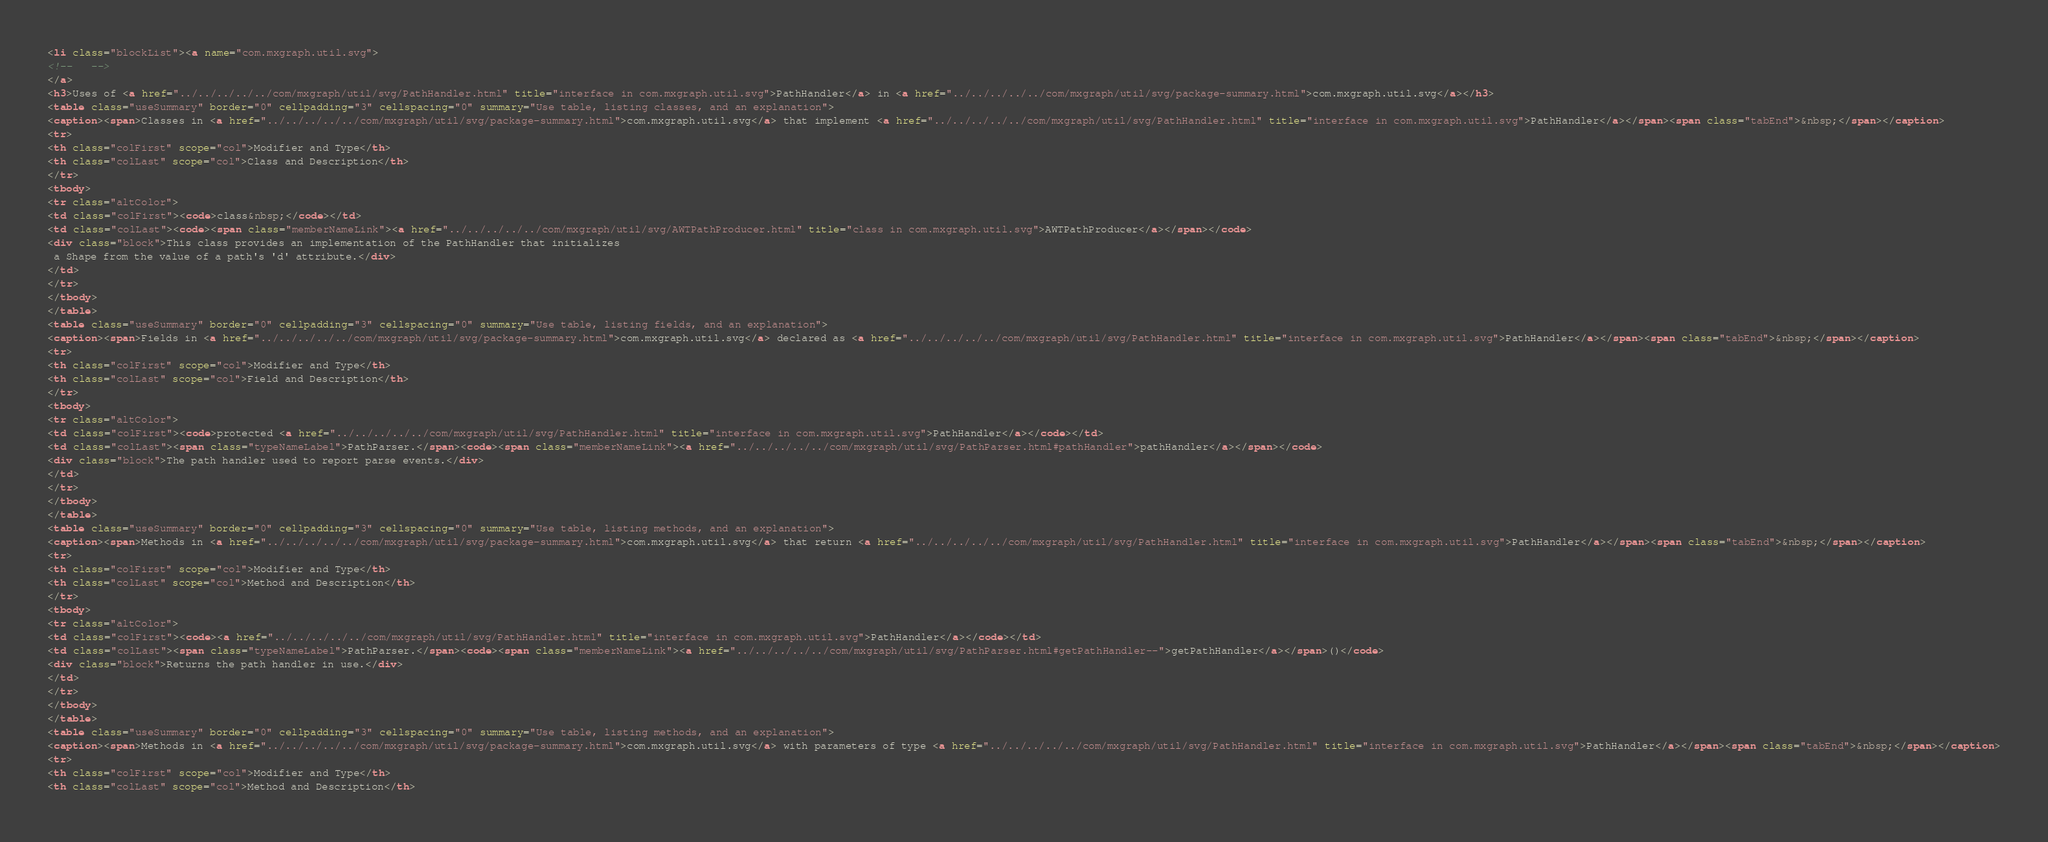<code> <loc_0><loc_0><loc_500><loc_500><_HTML_><li class="blockList"><a name="com.mxgraph.util.svg">
<!--   -->
</a>
<h3>Uses of <a href="../../../../../com/mxgraph/util/svg/PathHandler.html" title="interface in com.mxgraph.util.svg">PathHandler</a> in <a href="../../../../../com/mxgraph/util/svg/package-summary.html">com.mxgraph.util.svg</a></h3>
<table class="useSummary" border="0" cellpadding="3" cellspacing="0" summary="Use table, listing classes, and an explanation">
<caption><span>Classes in <a href="../../../../../com/mxgraph/util/svg/package-summary.html">com.mxgraph.util.svg</a> that implement <a href="../../../../../com/mxgraph/util/svg/PathHandler.html" title="interface in com.mxgraph.util.svg">PathHandler</a></span><span class="tabEnd">&nbsp;</span></caption>
<tr>
<th class="colFirst" scope="col">Modifier and Type</th>
<th class="colLast" scope="col">Class and Description</th>
</tr>
<tbody>
<tr class="altColor">
<td class="colFirst"><code>class&nbsp;</code></td>
<td class="colLast"><code><span class="memberNameLink"><a href="../../../../../com/mxgraph/util/svg/AWTPathProducer.html" title="class in com.mxgraph.util.svg">AWTPathProducer</a></span></code>
<div class="block">This class provides an implementation of the PathHandler that initializes
 a Shape from the value of a path's 'd' attribute.</div>
</td>
</tr>
</tbody>
</table>
<table class="useSummary" border="0" cellpadding="3" cellspacing="0" summary="Use table, listing fields, and an explanation">
<caption><span>Fields in <a href="../../../../../com/mxgraph/util/svg/package-summary.html">com.mxgraph.util.svg</a> declared as <a href="../../../../../com/mxgraph/util/svg/PathHandler.html" title="interface in com.mxgraph.util.svg">PathHandler</a></span><span class="tabEnd">&nbsp;</span></caption>
<tr>
<th class="colFirst" scope="col">Modifier and Type</th>
<th class="colLast" scope="col">Field and Description</th>
</tr>
<tbody>
<tr class="altColor">
<td class="colFirst"><code>protected <a href="../../../../../com/mxgraph/util/svg/PathHandler.html" title="interface in com.mxgraph.util.svg">PathHandler</a></code></td>
<td class="colLast"><span class="typeNameLabel">PathParser.</span><code><span class="memberNameLink"><a href="../../../../../com/mxgraph/util/svg/PathParser.html#pathHandler">pathHandler</a></span></code>
<div class="block">The path handler used to report parse events.</div>
</td>
</tr>
</tbody>
</table>
<table class="useSummary" border="0" cellpadding="3" cellspacing="0" summary="Use table, listing methods, and an explanation">
<caption><span>Methods in <a href="../../../../../com/mxgraph/util/svg/package-summary.html">com.mxgraph.util.svg</a> that return <a href="../../../../../com/mxgraph/util/svg/PathHandler.html" title="interface in com.mxgraph.util.svg">PathHandler</a></span><span class="tabEnd">&nbsp;</span></caption>
<tr>
<th class="colFirst" scope="col">Modifier and Type</th>
<th class="colLast" scope="col">Method and Description</th>
</tr>
<tbody>
<tr class="altColor">
<td class="colFirst"><code><a href="../../../../../com/mxgraph/util/svg/PathHandler.html" title="interface in com.mxgraph.util.svg">PathHandler</a></code></td>
<td class="colLast"><span class="typeNameLabel">PathParser.</span><code><span class="memberNameLink"><a href="../../../../../com/mxgraph/util/svg/PathParser.html#getPathHandler--">getPathHandler</a></span>()</code>
<div class="block">Returns the path handler in use.</div>
</td>
</tr>
</tbody>
</table>
<table class="useSummary" border="0" cellpadding="3" cellspacing="0" summary="Use table, listing methods, and an explanation">
<caption><span>Methods in <a href="../../../../../com/mxgraph/util/svg/package-summary.html">com.mxgraph.util.svg</a> with parameters of type <a href="../../../../../com/mxgraph/util/svg/PathHandler.html" title="interface in com.mxgraph.util.svg">PathHandler</a></span><span class="tabEnd">&nbsp;</span></caption>
<tr>
<th class="colFirst" scope="col">Modifier and Type</th>
<th class="colLast" scope="col">Method and Description</th></code> 